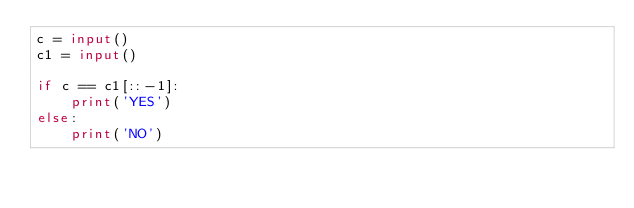Convert code to text. <code><loc_0><loc_0><loc_500><loc_500><_Python_>c = input()
c1 = input()

if c == c1[::-1]:
    print('YES')
else:
    print('NO')</code> 